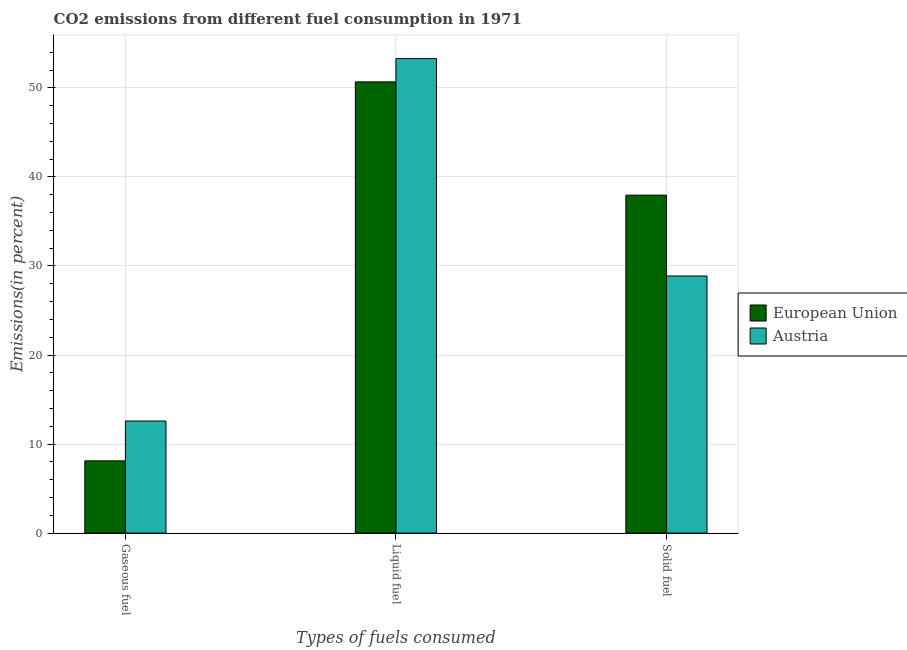How many different coloured bars are there?
Your answer should be compact. 2. How many groups of bars are there?
Keep it short and to the point. 3. Are the number of bars on each tick of the X-axis equal?
Provide a short and direct response. Yes. How many bars are there on the 2nd tick from the right?
Your response must be concise. 2. What is the label of the 1st group of bars from the left?
Keep it short and to the point. Gaseous fuel. What is the percentage of liquid fuel emission in Austria?
Your answer should be very brief. 53.29. Across all countries, what is the maximum percentage of solid fuel emission?
Make the answer very short. 37.96. Across all countries, what is the minimum percentage of liquid fuel emission?
Offer a very short reply. 50.68. In which country was the percentage of liquid fuel emission minimum?
Your answer should be very brief. European Union. What is the total percentage of solid fuel emission in the graph?
Provide a short and direct response. 66.83. What is the difference between the percentage of liquid fuel emission in European Union and that in Austria?
Provide a short and direct response. -2.62. What is the difference between the percentage of solid fuel emission in Austria and the percentage of liquid fuel emission in European Union?
Offer a terse response. -21.8. What is the average percentage of liquid fuel emission per country?
Your answer should be compact. 51.99. What is the difference between the percentage of solid fuel emission and percentage of gaseous fuel emission in European Union?
Your answer should be very brief. 29.84. What is the ratio of the percentage of gaseous fuel emission in Austria to that in European Union?
Make the answer very short. 1.55. What is the difference between the highest and the second highest percentage of solid fuel emission?
Offer a terse response. 9.08. What is the difference between the highest and the lowest percentage of solid fuel emission?
Provide a succinct answer. 9.08. What does the 1st bar from the right in Solid fuel represents?
Make the answer very short. Austria. How many countries are there in the graph?
Provide a short and direct response. 2. What is the difference between two consecutive major ticks on the Y-axis?
Your response must be concise. 10. Does the graph contain grids?
Your response must be concise. Yes. Where does the legend appear in the graph?
Give a very brief answer. Center right. How are the legend labels stacked?
Ensure brevity in your answer.  Vertical. What is the title of the graph?
Offer a very short reply. CO2 emissions from different fuel consumption in 1971. What is the label or title of the X-axis?
Your response must be concise. Types of fuels consumed. What is the label or title of the Y-axis?
Offer a terse response. Emissions(in percent). What is the Emissions(in percent) of European Union in Gaseous fuel?
Your answer should be very brief. 8.11. What is the Emissions(in percent) of Austria in Gaseous fuel?
Offer a very short reply. 12.59. What is the Emissions(in percent) of European Union in Liquid fuel?
Make the answer very short. 50.68. What is the Emissions(in percent) of Austria in Liquid fuel?
Keep it short and to the point. 53.29. What is the Emissions(in percent) in European Union in Solid fuel?
Provide a succinct answer. 37.96. What is the Emissions(in percent) of Austria in Solid fuel?
Ensure brevity in your answer.  28.88. Across all Types of fuels consumed, what is the maximum Emissions(in percent) in European Union?
Provide a succinct answer. 50.68. Across all Types of fuels consumed, what is the maximum Emissions(in percent) in Austria?
Ensure brevity in your answer.  53.29. Across all Types of fuels consumed, what is the minimum Emissions(in percent) in European Union?
Offer a terse response. 8.11. Across all Types of fuels consumed, what is the minimum Emissions(in percent) of Austria?
Make the answer very short. 12.59. What is the total Emissions(in percent) in European Union in the graph?
Keep it short and to the point. 96.75. What is the total Emissions(in percent) in Austria in the graph?
Ensure brevity in your answer.  94.75. What is the difference between the Emissions(in percent) in European Union in Gaseous fuel and that in Liquid fuel?
Offer a terse response. -42.57. What is the difference between the Emissions(in percent) in Austria in Gaseous fuel and that in Liquid fuel?
Provide a short and direct response. -40.71. What is the difference between the Emissions(in percent) in European Union in Gaseous fuel and that in Solid fuel?
Ensure brevity in your answer.  -29.84. What is the difference between the Emissions(in percent) in Austria in Gaseous fuel and that in Solid fuel?
Offer a very short reply. -16.29. What is the difference between the Emissions(in percent) of European Union in Liquid fuel and that in Solid fuel?
Provide a succinct answer. 12.72. What is the difference between the Emissions(in percent) in Austria in Liquid fuel and that in Solid fuel?
Provide a short and direct response. 24.42. What is the difference between the Emissions(in percent) in European Union in Gaseous fuel and the Emissions(in percent) in Austria in Liquid fuel?
Give a very brief answer. -45.18. What is the difference between the Emissions(in percent) in European Union in Gaseous fuel and the Emissions(in percent) in Austria in Solid fuel?
Provide a short and direct response. -20.76. What is the difference between the Emissions(in percent) of European Union in Liquid fuel and the Emissions(in percent) of Austria in Solid fuel?
Make the answer very short. 21.8. What is the average Emissions(in percent) in European Union per Types of fuels consumed?
Provide a succinct answer. 32.25. What is the average Emissions(in percent) in Austria per Types of fuels consumed?
Your answer should be very brief. 31.59. What is the difference between the Emissions(in percent) in European Union and Emissions(in percent) in Austria in Gaseous fuel?
Ensure brevity in your answer.  -4.47. What is the difference between the Emissions(in percent) in European Union and Emissions(in percent) in Austria in Liquid fuel?
Give a very brief answer. -2.62. What is the difference between the Emissions(in percent) in European Union and Emissions(in percent) in Austria in Solid fuel?
Provide a succinct answer. 9.08. What is the ratio of the Emissions(in percent) of European Union in Gaseous fuel to that in Liquid fuel?
Give a very brief answer. 0.16. What is the ratio of the Emissions(in percent) of Austria in Gaseous fuel to that in Liquid fuel?
Provide a short and direct response. 0.24. What is the ratio of the Emissions(in percent) of European Union in Gaseous fuel to that in Solid fuel?
Offer a terse response. 0.21. What is the ratio of the Emissions(in percent) in Austria in Gaseous fuel to that in Solid fuel?
Your response must be concise. 0.44. What is the ratio of the Emissions(in percent) of European Union in Liquid fuel to that in Solid fuel?
Provide a short and direct response. 1.34. What is the ratio of the Emissions(in percent) in Austria in Liquid fuel to that in Solid fuel?
Keep it short and to the point. 1.85. What is the difference between the highest and the second highest Emissions(in percent) of European Union?
Provide a short and direct response. 12.72. What is the difference between the highest and the second highest Emissions(in percent) of Austria?
Give a very brief answer. 24.42. What is the difference between the highest and the lowest Emissions(in percent) in European Union?
Keep it short and to the point. 42.57. What is the difference between the highest and the lowest Emissions(in percent) of Austria?
Your response must be concise. 40.71. 